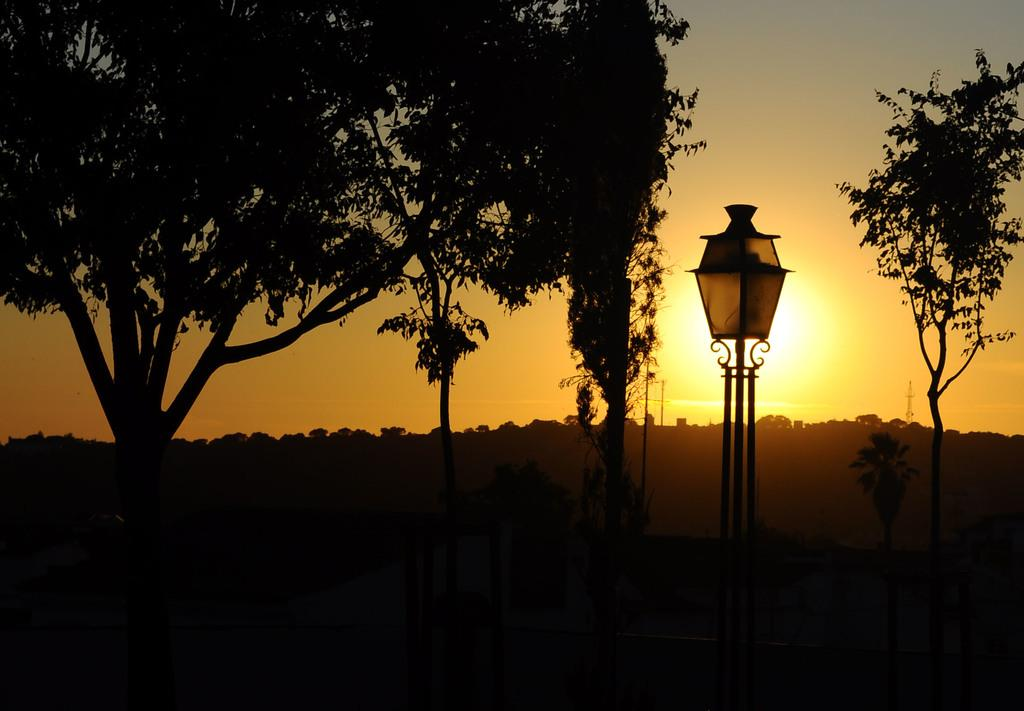What can be seen in the sky in the image? The sky is visible in the image, and the sun is present in the sky. What type of natural vegetation is in the image? There are trees in the image. What type of man-made structure is in the image? There is a streetlight on a stand in the image. What type of disease is affecting the trees in the image? There is no indication of any disease affecting the trees in the image; they appear healthy. Can you describe the group of people gathered around the streetlight in the image? There are no people present in the image; only the streetlight, trees, and sky are visible. 